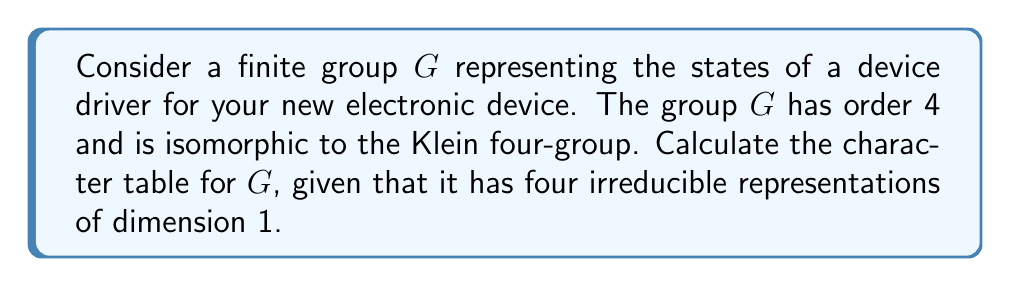Could you help me with this problem? Let's approach this step-by-step:

1) First, recall that the Klein four-group has four elements, which we can denote as $\{e, a, b, c\}$, where $e$ is the identity element.

2) The group multiplication table for the Klein four-group is:

   $$\begin{array}{c|cccc}
     & e & a & b & c \\
   \hline
   e & e & a & b & c \\
   a & a & e & c & b \\
   b & b & c & e & a \\
   c & c & b & a & e
   \end{array}$$

3) Since $G$ has four irreducible representations of dimension 1, the character table will be a 4x4 matrix.

4) The first row of the character table always corresponds to the trivial representation, where all elements map to 1:

   $$\chi_1: \{1, 1, 1, 1\}$$

5) For the remaining three representations, we know that:
   - Characters are homomorphisms from $G$ to $\mathbb{C}^*$
   - The values must be 4th roots of unity (as $g^4 = e$ for all $g \in G$)
   - The only 4th roots of unity are $\{1, -1, i, -i\}$, but since the characters are real-valued for this group, we only use $\{1, -1\}$

6) Given the structure of the Klein four-group, we can deduce the remaining rows:

   $$\chi_2: \{1, -1, 1, -1\}$$
   $$\chi_3: \{1, 1, -1, -1\}$$
   $$\chi_4: \{1, -1, -1, 1\}$$

7) Therefore, the complete character table is:

   $$\begin{array}{c|cccc}
      & e & a & b & c \\
   \hline
   \chi_1 & 1 & 1 & 1 & 1 \\
   \chi_2 & 1 & -1 & 1 & -1 \\
   \chi_3 & 1 & 1 & -1 & -1 \\
   \chi_4 & 1 & -1 & -1 & 1
   \end{array}$$

This character table satisfies all the required properties, including orthogonality of rows and columns.
Answer: $$\begin{array}{c|cccc}
   & e & a & b & c \\
\hline
\chi_1 & 1 & 1 & 1 & 1 \\
\chi_2 & 1 & -1 & 1 & -1 \\
\chi_3 & 1 & 1 & -1 & -1 \\
\chi_4 & 1 & -1 & -1 & 1
\end{array}$$ 